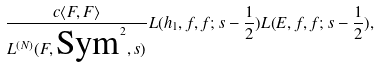Convert formula to latex. <formula><loc_0><loc_0><loc_500><loc_500>\frac { c \langle F , F \rangle } { L ^ { ( N ) } ( F , \text {Sym} ^ { 2 } , s ) } L ( h _ { 1 } , f , f ; s - \frac { 1 } { 2 } ) L ( E , f , f ; s - \frac { 1 } { 2 } ) ,</formula> 